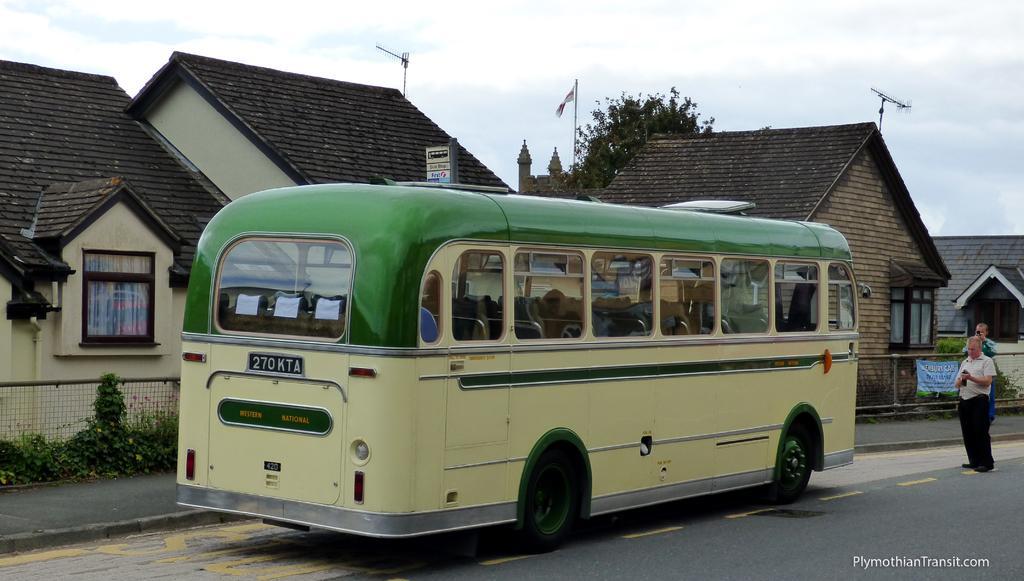In one or two sentences, can you explain what this image depicts? In this image we can see a motor vehicle on the road, persons standing on the road, advertisement attached to the fence, creepers, buildings, flags, antennas, trees and sky with clouds. 